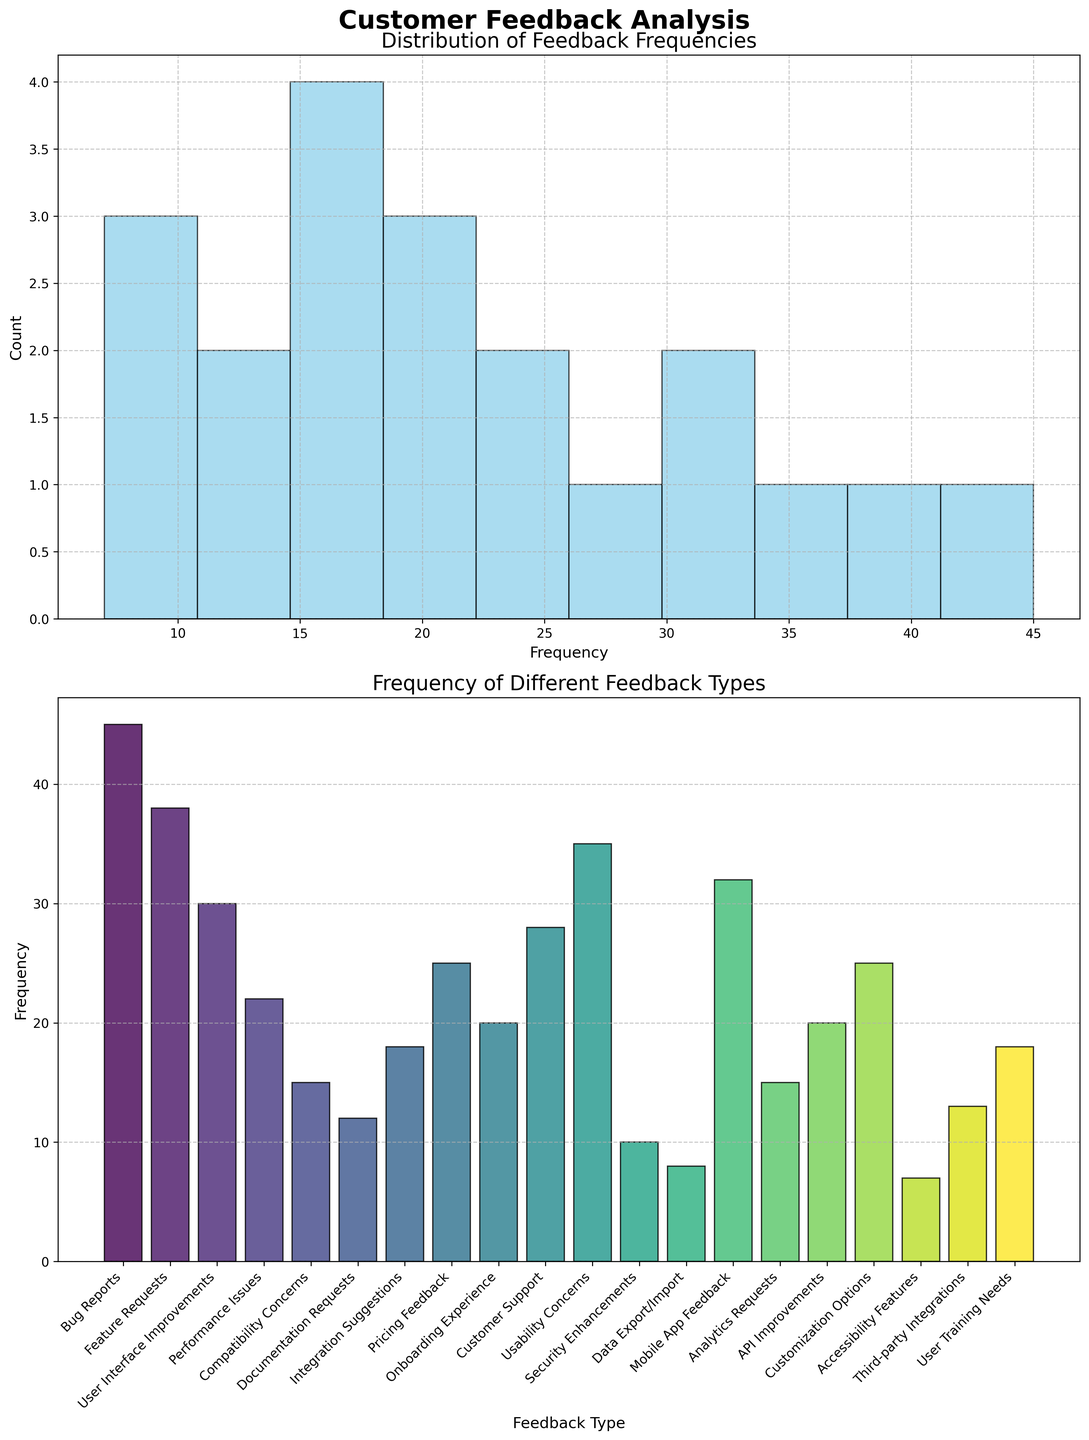How many bins are used in the histogram? The histogram shows a distribution split into discrete sections, the number of these sections represents the bins. By visually counting, we can see 10 distinct sections.
Answer: 10 What's the title of the bar plot? We can read the title situated above the bar plot directly.
Answer: Frequency of Different Feedback Types Which feedback type has the highest frequency? We need to look for the tallest bar in the bar plot. The tallest bar corresponds to "Bug Reports" with a frequency of 45.
Answer: Bug Reports How does the frequency of "User Interface Improvements" compare to that of "Performance Issues"? We find the bars corresponding to these two feedback types in the bar plot and compare their heights. "User Interface Improvements" has a frequency of 30, while "Performance Issues" has a frequency of 22.
Answer: "User Interface Improvements" > "Performance Issues" What is the total frequency of "Pricing Feedback" and "API Improvements"? Identify the bars for "Pricing Feedback" (25) and "API Improvements" (20) and sum their frequencies. 25 + 20 = 45
Answer: 45 What is the average frequency of the feedback types shown? Calculate the sum of all frequencies and divide by the number of feedback types. (45 + 38 + 30 + 22 + 15 + 12 + 18 + 25 + 20 + 28 + 35 + 10 + 8 + 32 + 15 + 20 + 25 + 7 + 13 + 18) / 20 = 451 / 20 = 22.55
Answer: 22.55 Which feedback type has the lowest frequency? Identify the shortest bar in the bar plot. The shortest bar corresponds to the "Accessibility Features" with a frequency of 7.
Answer: Accessibility Features How many feedback types have a frequency greater than 30? Count the number of bars that exceed the 30 frequency mark. There are four such bars: "Bug Reports", "Feature Requests", "Usability Concerns", and "Mobile App Feedback".
Answer: 4 What is the combined frequency of all feedback types shown on the bar plot? Sum up all the frequencies indicated by the bars: 45 + 38 + 30 + 22 + 15 + 12 + 18 + 25 + 20 + 28 + 35 + 10 + 8 + 32 + 15 + 20 + 25 + 7 + 13 + 18 = 451
Answer: 451 How does the frequency distribution in the histogram compare in terms of skewness? Observe the shape of the histogram distribution. It appears that a majority of the frequency counts are towards the lower ranges, suggesting that the distribution is skewed to the right.
Answer: Skewed to the right 